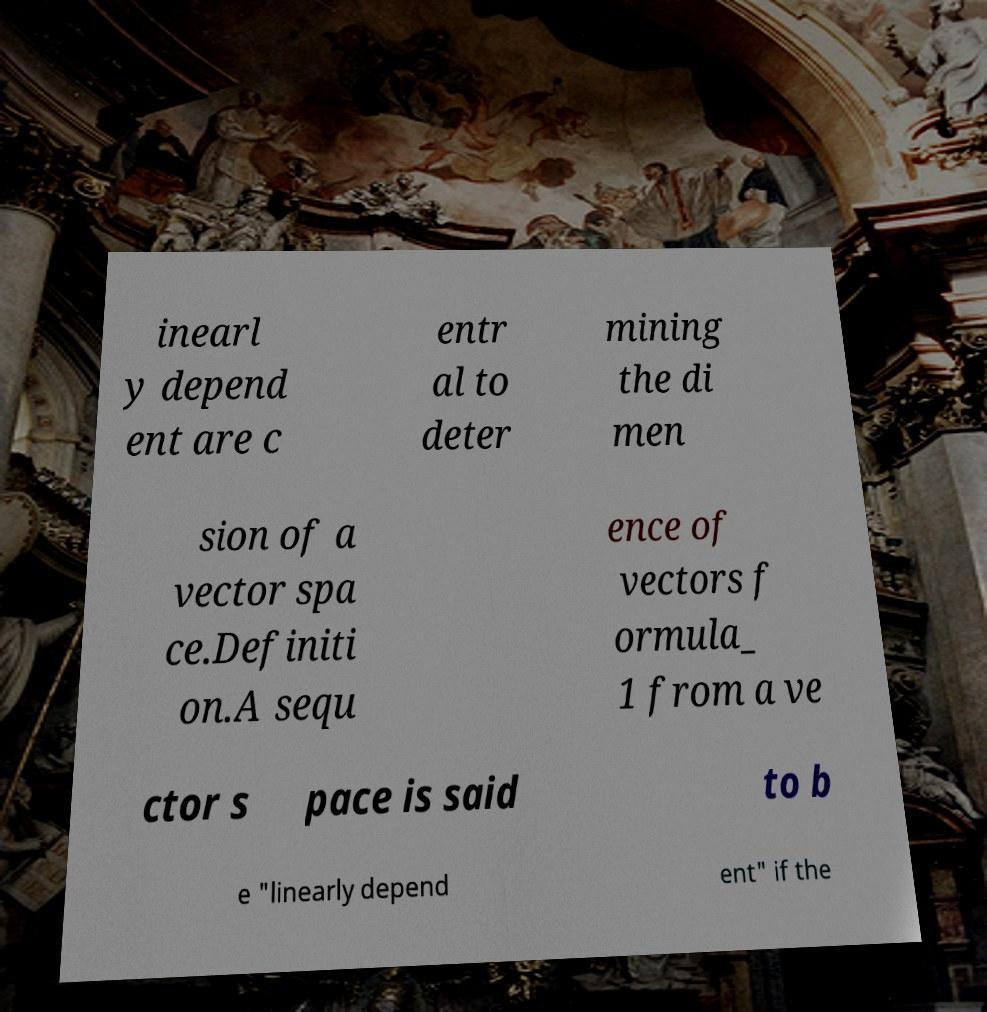Please identify and transcribe the text found in this image. inearl y depend ent are c entr al to deter mining the di men sion of a vector spa ce.Definiti on.A sequ ence of vectors f ormula_ 1 from a ve ctor s pace is said to b e "linearly depend ent" if the 